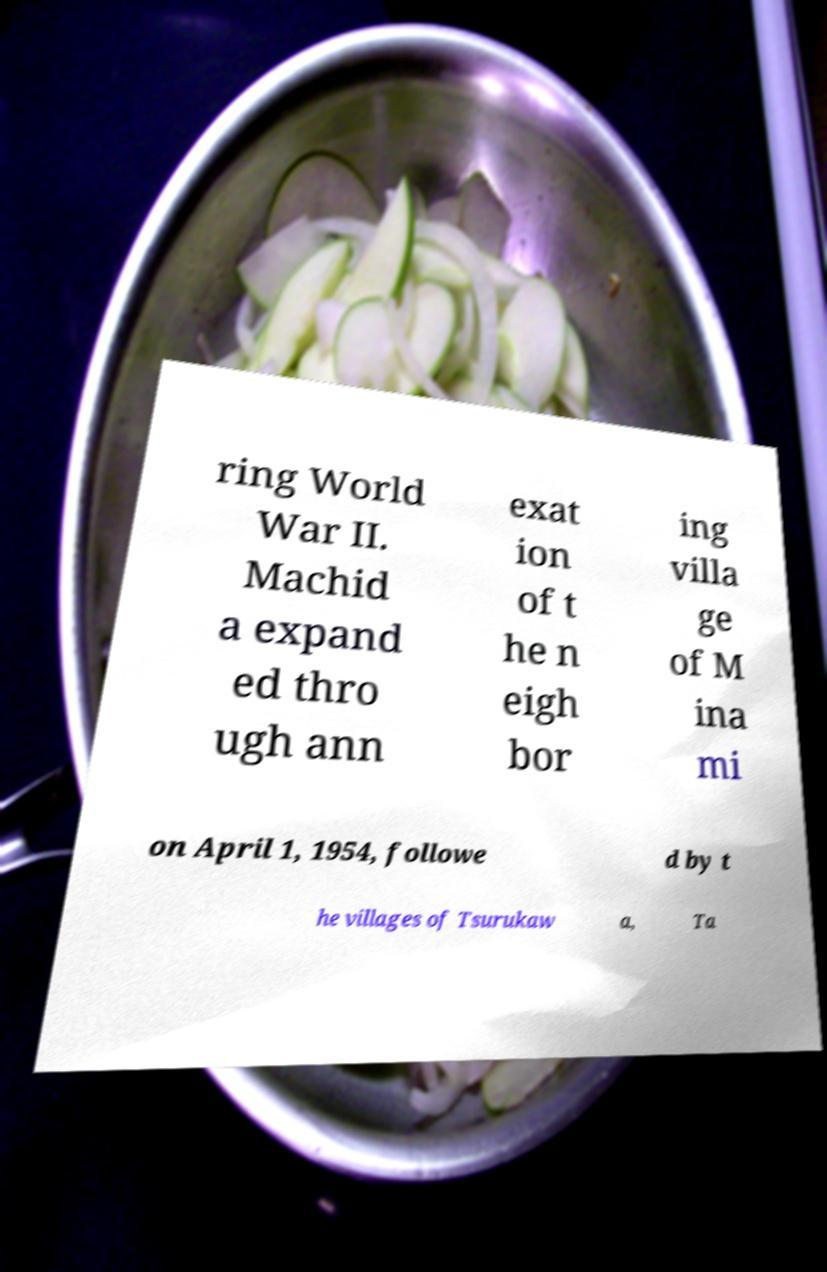I need the written content from this picture converted into text. Can you do that? ring World War II. Machid a expand ed thro ugh ann exat ion of t he n eigh bor ing villa ge of M ina mi on April 1, 1954, followe d by t he villages of Tsurukaw a, Ta 